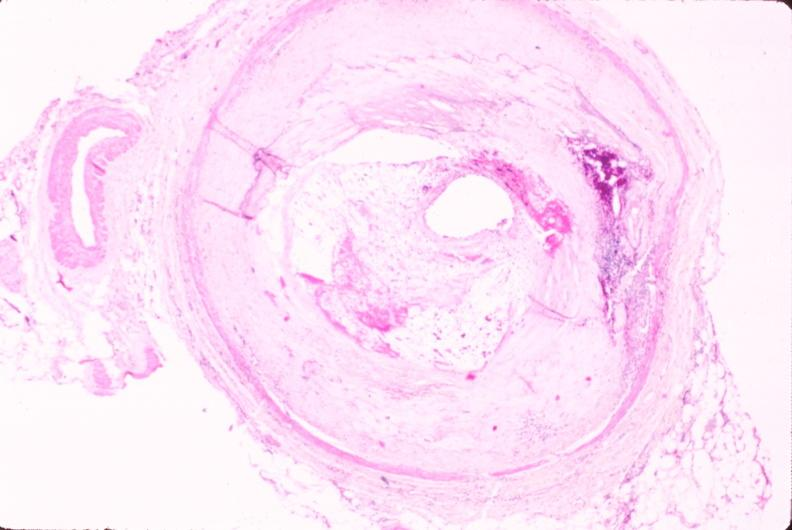s cranial artery present?
Answer the question using a single word or phrase. No 